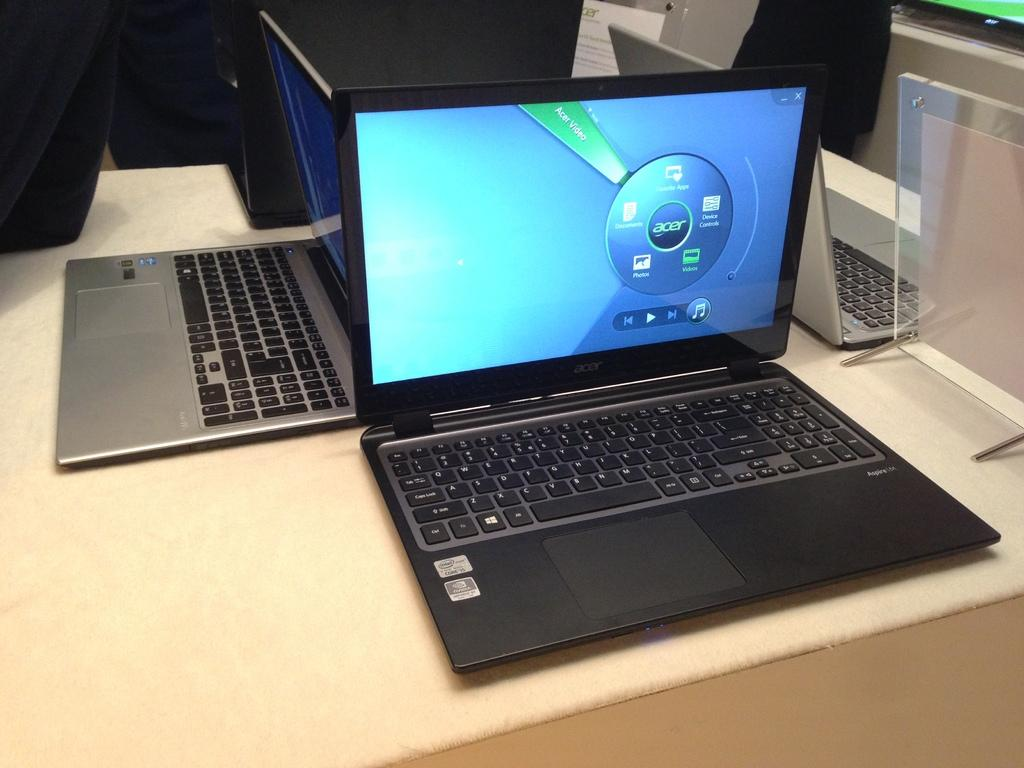<image>
Relay a brief, clear account of the picture shown. An open laptop's screen has an icon for the brand Acer. 